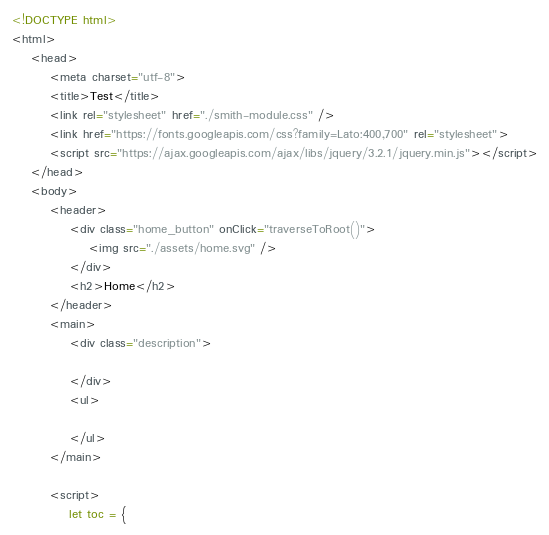Convert code to text. <code><loc_0><loc_0><loc_500><loc_500><_HTML_><!DOCTYPE html>
<html>
    <head>
        <meta charset="utf-8">
        <title>Test</title>
        <link rel="stylesheet" href="./smith-module.css" />
        <link href="https://fonts.googleapis.com/css?family=Lato:400,700" rel="stylesheet">
        <script src="https://ajax.googleapis.com/ajax/libs/jquery/3.2.1/jquery.min.js"></script>
    </head>
    <body>
        <header>
            <div class="home_button" onClick="traverseToRoot()">
                <img src="./assets/home.svg" />
            </div>
            <h2>Home</h2>
        </header>
        <main>
            <div class="description">

            </div>
            <ul>

            </ul>
        </main>

        <script>
            let toc = {</code> 